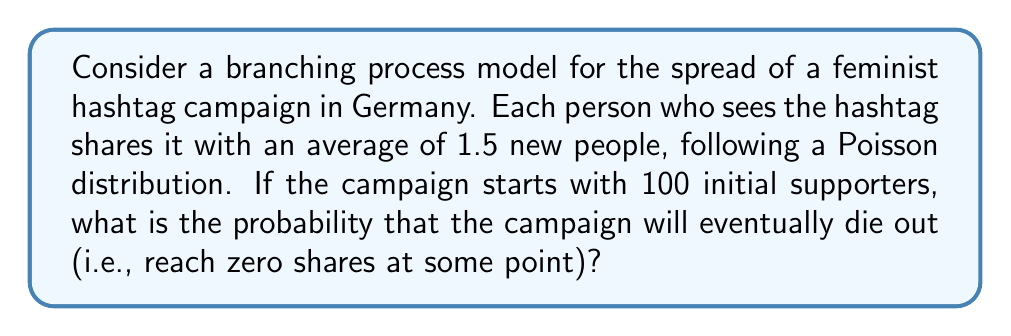Can you answer this question? To solve this problem, we'll use the theory of branching processes:

1. In a branching process, the extinction probability $q$ satisfies the equation:
   $q = G(q)$, where $G(s)$ is the probability generating function of the offspring distribution.

2. For a Poisson distribution with mean $\lambda = 1.5$, the probability generating function is:
   $G(s) = e^{\lambda(s-1)} = e^{1.5(s-1)}$

3. We need to solve the equation:
   $q = e^{1.5(q-1)}$

4. This equation can't be solved analytically, but we can find the solution numerically.
   Using numerical methods (e.g., Newton's method), we find that $q \approx 0.1173$.

5. The probability that the campaign dies out when starting with 100 initial supporters is:
   $P(\text{extinction}) = q^{100}$

6. Calculate:
   $P(\text{extinction}) = 0.1173^{100} \approx 1.062 \times 10^{-90}$

This extremely small probability indicates that the campaign is very likely to continue indefinitely.
Answer: $1.062 \times 10^{-90}$ 